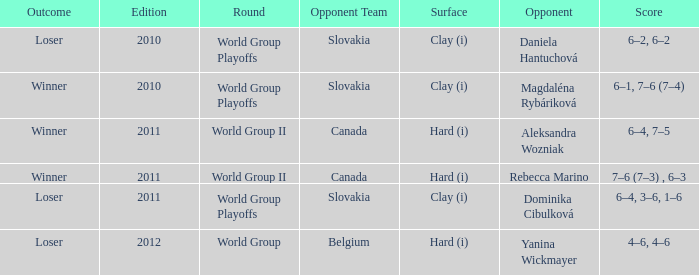How many outcomes were there when the opponent was Aleksandra Wozniak? 1.0. 